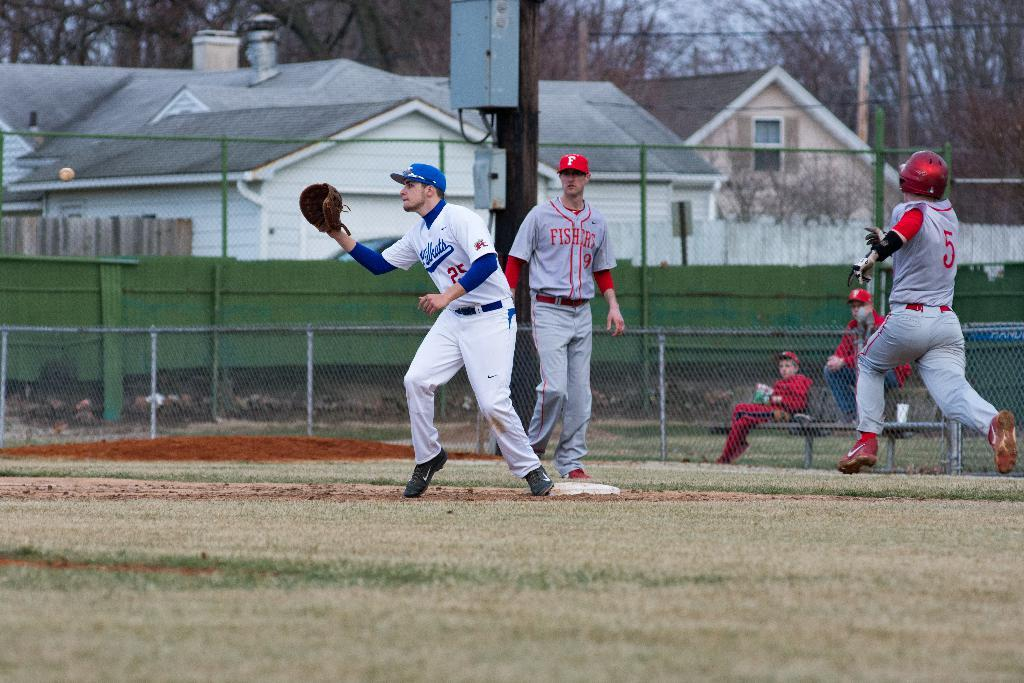<image>
Share a concise interpretation of the image provided. A group of baseball players in a game on jersey says fishers. 